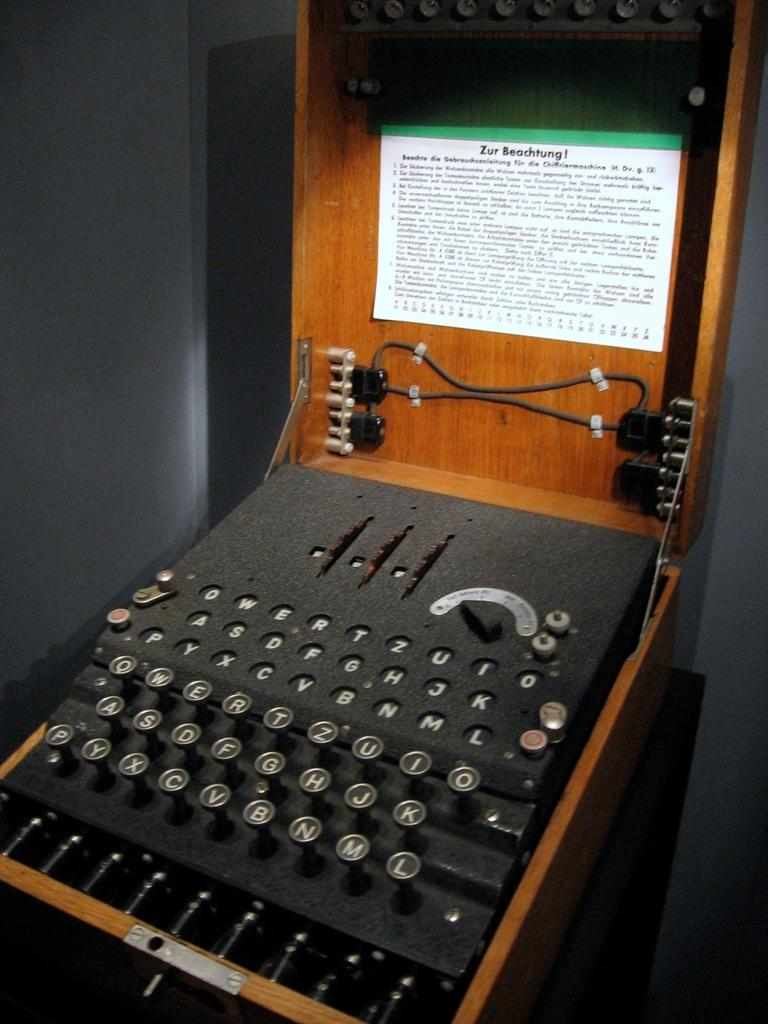<image>
Relay a brief, clear account of the picture shown. An old typing device is in a wooden case with a paper above it that says "Zur Beachtung!" 